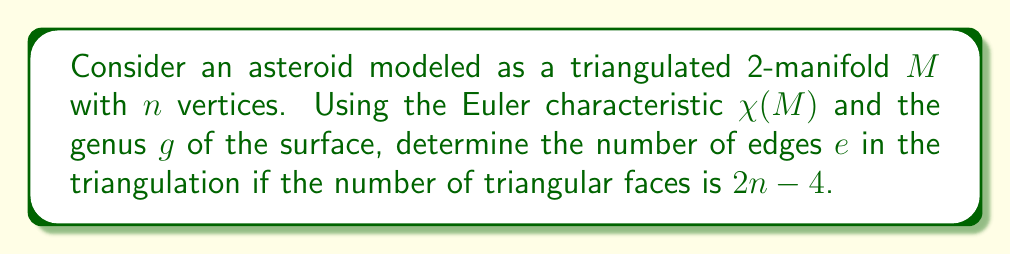Solve this math problem. Let's approach this step-by-step:

1) For a closed orientable surface, the Euler characteristic $\chi(M)$ is related to the genus $g$ by:

   $$\chi(M) = 2 - 2g$$

2) The Euler characteristic is also defined as:

   $$\chi(M) = v - e + f$$

   where $v$ is the number of vertices, $e$ is the number of edges, and $f$ is the number of faces.

3) We're given that the number of vertices is $n$ and the number of faces is $2n-4$.

4) Substituting these into the Euler characteristic equation:

   $$2 - 2g = n - e + (2n-4)$$

5) Simplifying:

   $$2 - 2g = 3n - 4 - e$$

6) Solving for $e$:

   $$e = 3n - 6 + 2g$$

This formula gives us the number of edges in the triangulation based on the number of vertices and the genus of the surface.

For an irregularly shaped asteroid, the genus could be non-zero, allowing for the modeling of features like tunnels or holes in the asteroid's structure. This topological approach provides a framework for describing the asteroid's shape, which is crucial for accurately modeling its gravitational field.
Answer: $e = 3n - 6 + 2g$ 